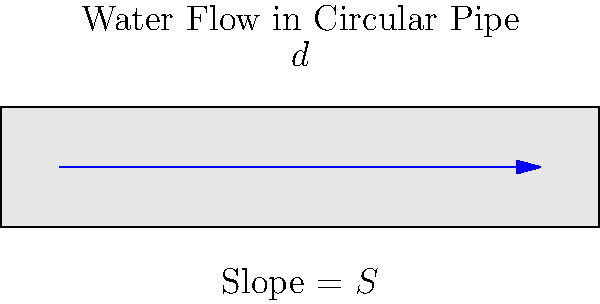In a circular pipe with diameter $d$ and slope $S$, how can you estimate the water flow rate $Q$ using Manning's equation? Assume the pipe is flowing full and the Manning's roughness coefficient $n$ is known. To estimate the water flow rate through a circular pipe, we can use Manning's equation. Here's a step-by-step explanation:

1. Manning's equation for full pipe flow is:
   
   $$Q = \frac{1}{n} A R^{2/3} S^{1/2}$$

   Where:
   $Q$ = flow rate (m³/s)
   $n$ = Manning's roughness coefficient
   $A$ = cross-sectional area of flow (m²)
   $R$ = hydraulic radius (m)
   $S$ = slope of the pipe

2. For a circular pipe flowing full:
   
   Area: $A = \frac{\pi d^2}{4}$
   
   Hydraulic radius: $R = \frac{d}{4}$

3. Substituting these into Manning's equation:

   $$Q = \frac{1}{n} \cdot \frac{\pi d^2}{4} \cdot (\frac{d}{4})^{2/3} \cdot S^{1/2}$$

4. Simplifying:

   $$Q = \frac{\pi}{4n} \cdot d^{2.67} \cdot S^{0.5}$$

5. This equation allows you to estimate the flow rate $Q$ given the pipe diameter $d$, slope $S$, and Manning's roughness coefficient $n$.
Answer: $Q = \frac{\pi}{4n} \cdot d^{2.67} \cdot S^{0.5}$ 